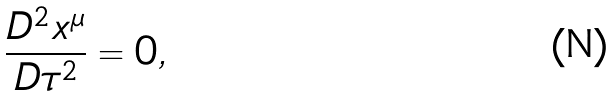Convert formula to latex. <formula><loc_0><loc_0><loc_500><loc_500>\frac { D ^ { 2 } x ^ { \mu } } { D \tau ^ { 2 } } = 0 ,</formula> 